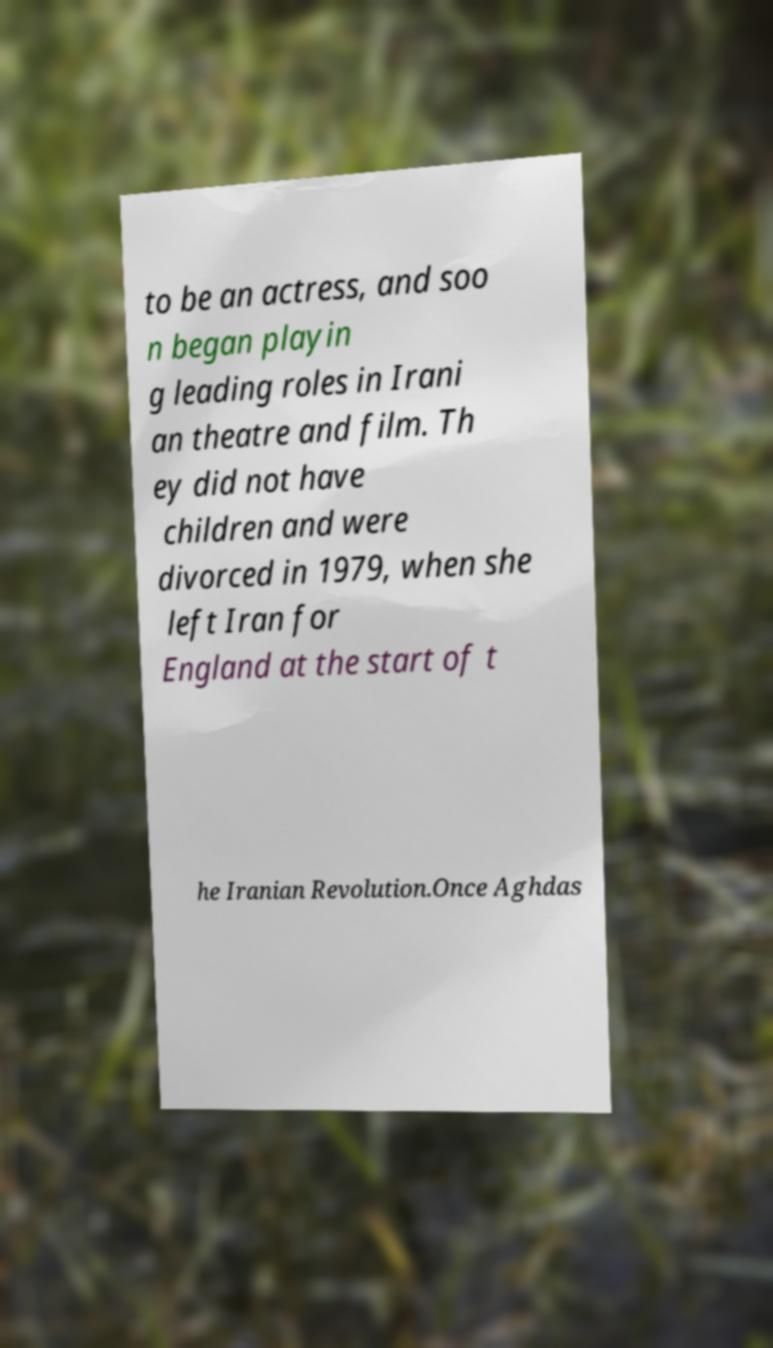For documentation purposes, I need the text within this image transcribed. Could you provide that? to be an actress, and soo n began playin g leading roles in Irani an theatre and film. Th ey did not have children and were divorced in 1979, when she left Iran for England at the start of t he Iranian Revolution.Once Aghdas 